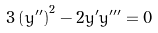Convert formula to latex. <formula><loc_0><loc_0><loc_500><loc_500>3 \left ( y ^ { \prime \prime } \right ) ^ { 2 } - 2 y ^ { \prime } y ^ { \prime \prime \prime } = 0</formula> 